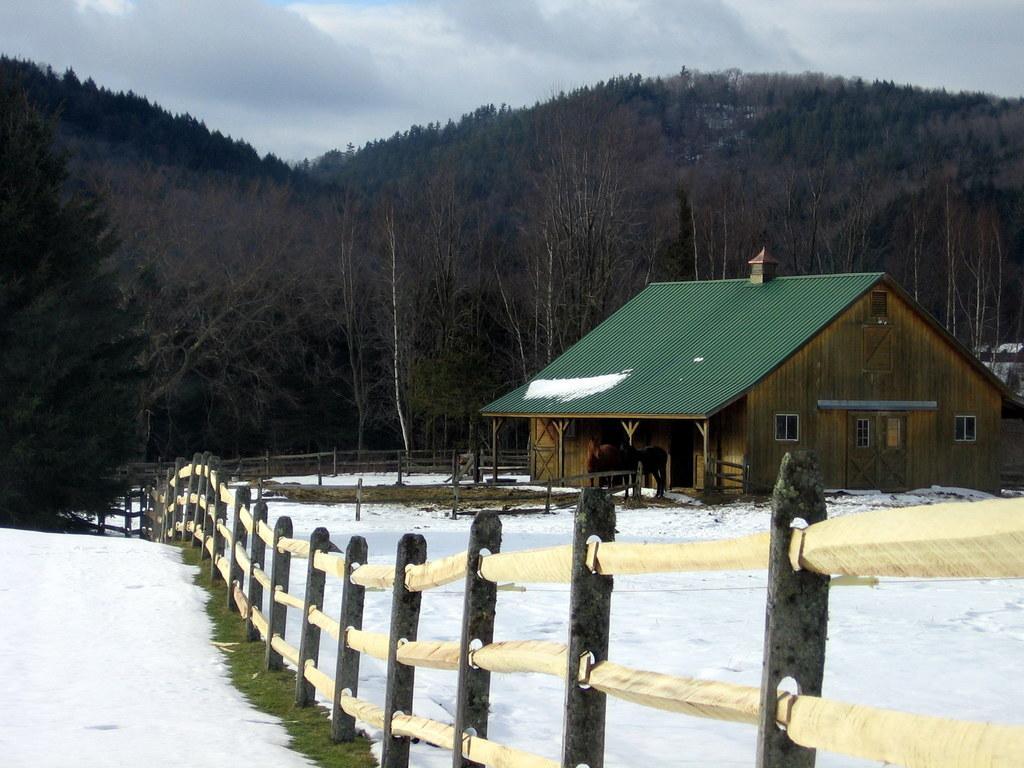Could you give a brief overview of what you see in this image? Sky is cloudy. Here we can see fence house with windows and rooftop. In-front of this house there are horses. Background there are trees. Land is covered with snow. 